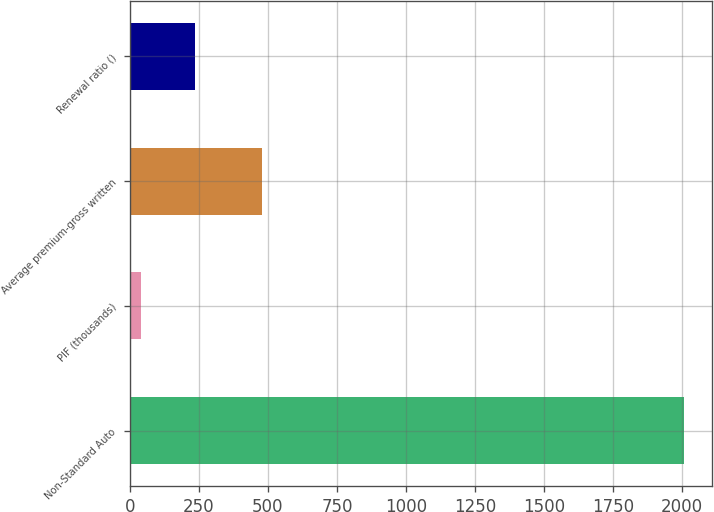<chart> <loc_0><loc_0><loc_500><loc_500><bar_chart><fcel>Non-Standard Auto<fcel>PIF (thousands)<fcel>Average premium-gross written<fcel>Renewal ratio ()<nl><fcel>2008<fcel>39<fcel>479<fcel>235.9<nl></chart> 